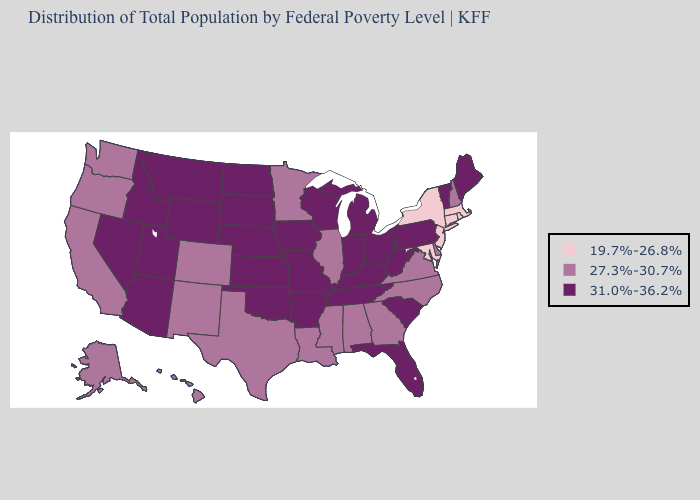Among the states that border Wyoming , which have the highest value?
Give a very brief answer. Idaho, Montana, Nebraska, South Dakota, Utah. What is the highest value in the Northeast ?
Give a very brief answer. 31.0%-36.2%. What is the value of Massachusetts?
Answer briefly. 19.7%-26.8%. Does North Dakota have the same value as Mississippi?
Write a very short answer. No. Among the states that border Louisiana , does Mississippi have the lowest value?
Write a very short answer. Yes. Among the states that border Wisconsin , does Michigan have the highest value?
Be succinct. Yes. Does Vermont have the highest value in the USA?
Give a very brief answer. Yes. What is the lowest value in the Northeast?
Give a very brief answer. 19.7%-26.8%. Name the states that have a value in the range 31.0%-36.2%?
Write a very short answer. Arizona, Arkansas, Florida, Idaho, Indiana, Iowa, Kansas, Kentucky, Maine, Michigan, Missouri, Montana, Nebraska, Nevada, North Dakota, Ohio, Oklahoma, Pennsylvania, South Carolina, South Dakota, Tennessee, Utah, Vermont, West Virginia, Wisconsin, Wyoming. Among the states that border Michigan , which have the lowest value?
Quick response, please. Indiana, Ohio, Wisconsin. What is the value of Oregon?
Concise answer only. 27.3%-30.7%. Among the states that border Wisconsin , does Illinois have the lowest value?
Write a very short answer. Yes. Does Arkansas have the highest value in the South?
Answer briefly. Yes. Name the states that have a value in the range 19.7%-26.8%?
Be succinct. Connecticut, Maryland, Massachusetts, New Jersey, New York, Rhode Island. What is the value of Hawaii?
Keep it brief. 27.3%-30.7%. 